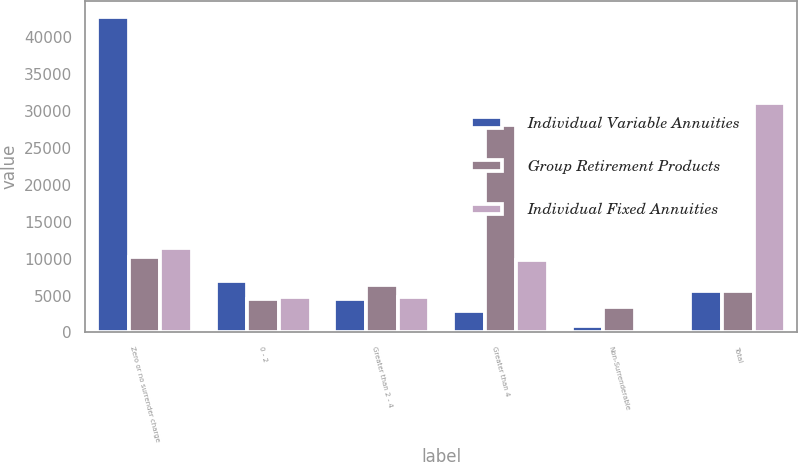Convert chart to OTSL. <chart><loc_0><loc_0><loc_500><loc_500><stacked_bar_chart><ecel><fcel>Zero or no surrender charge<fcel>0 - 2<fcel>Greater than 2 - 4<fcel>Greater than 4<fcel>Non-Surrenderable<fcel>Total<nl><fcel>Individual Variable Annuities<fcel>42741<fcel>6921<fcel>4573<fcel>2842<fcel>877<fcel>5645.5<nl><fcel>Group Retirement Products<fcel>10187<fcel>4503<fcel>6422<fcel>28109<fcel>3464<fcel>5645.5<nl><fcel>Individual Fixed Annuities<fcel>11467<fcel>4869<fcel>4830<fcel>9836<fcel>91<fcel>31093<nl></chart> 